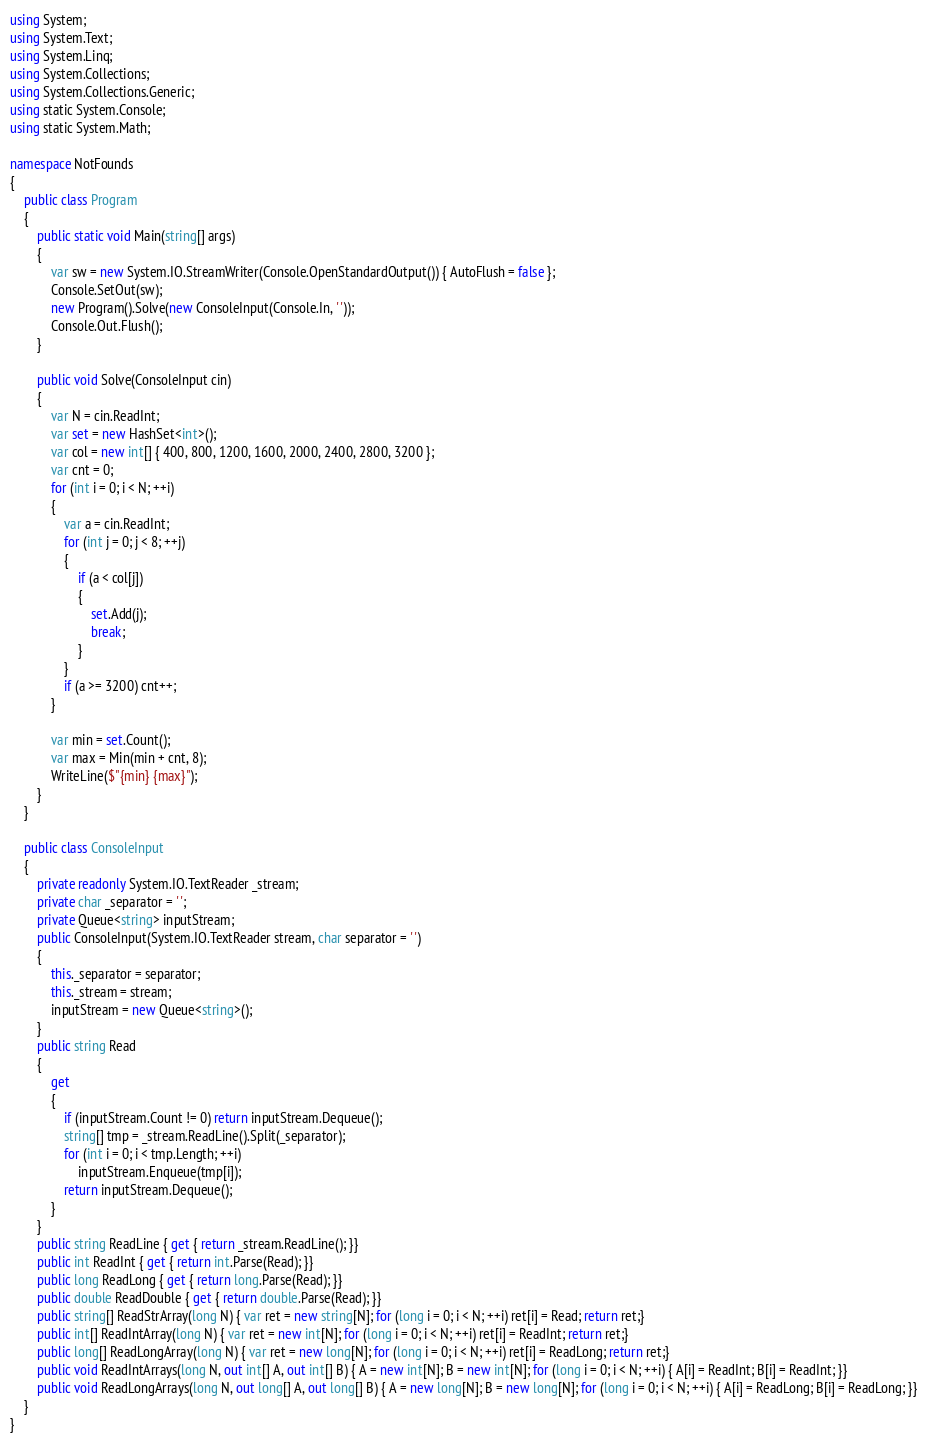<code> <loc_0><loc_0><loc_500><loc_500><_C#_>using System;
using System.Text;
using System.Linq;
using System.Collections;
using System.Collections.Generic;
using static System.Console;
using static System.Math;

namespace NotFounds
{
    public class Program
    {
        public static void Main(string[] args)
        {
            var sw = new System.IO.StreamWriter(Console.OpenStandardOutput()) { AutoFlush = false };
            Console.SetOut(sw);
            new Program().Solve(new ConsoleInput(Console.In, ' '));
            Console.Out.Flush();
        }

        public void Solve(ConsoleInput cin)
        {
            var N = cin.ReadInt;
            var set = new HashSet<int>();
            var col = new int[] { 400, 800, 1200, 1600, 2000, 2400, 2800, 3200 };
            var cnt = 0;
            for (int i = 0; i < N; ++i)
            {
                var a = cin.ReadInt;
                for (int j = 0; j < 8; ++j)
                {
                    if (a < col[j])
                    {
                        set.Add(j);
                        break;
                    }
                }
                if (a >= 3200) cnt++;
            }

            var min = set.Count();
            var max = Min(min + cnt, 8);
            WriteLine($"{min} {max}");
        }
    }

    public class ConsoleInput
    {
        private readonly System.IO.TextReader _stream;
        private char _separator = ' ';
        private Queue<string> inputStream;
        public ConsoleInput(System.IO.TextReader stream, char separator = ' ')
        {
            this._separator = separator;
            this._stream = stream;
            inputStream = new Queue<string>();
        }
        public string Read
        {
            get
            {
                if (inputStream.Count != 0) return inputStream.Dequeue();
                string[] tmp = _stream.ReadLine().Split(_separator);
                for (int i = 0; i < tmp.Length; ++i)
                    inputStream.Enqueue(tmp[i]);
                return inputStream.Dequeue();
            }
        }
        public string ReadLine { get { return _stream.ReadLine(); }}
        public int ReadInt { get { return int.Parse(Read); }}
        public long ReadLong { get { return long.Parse(Read); }}
        public double ReadDouble { get { return double.Parse(Read); }}
        public string[] ReadStrArray(long N) { var ret = new string[N]; for (long i = 0; i < N; ++i) ret[i] = Read; return ret;}
        public int[] ReadIntArray(long N) { var ret = new int[N]; for (long i = 0; i < N; ++i) ret[i] = ReadInt; return ret;}
        public long[] ReadLongArray(long N) { var ret = new long[N]; for (long i = 0; i < N; ++i) ret[i] = ReadLong; return ret;}
        public void ReadIntArrays(long N, out int[] A, out int[] B) { A = new int[N]; B = new int[N]; for (long i = 0; i < N; ++i) { A[i] = ReadInt; B[i] = ReadInt; }}
        public void ReadLongArrays(long N, out long[] A, out long[] B) { A = new long[N]; B = new long[N]; for (long i = 0; i < N; ++i) { A[i] = ReadLong; B[i] = ReadLong; }}
    }
}
</code> 